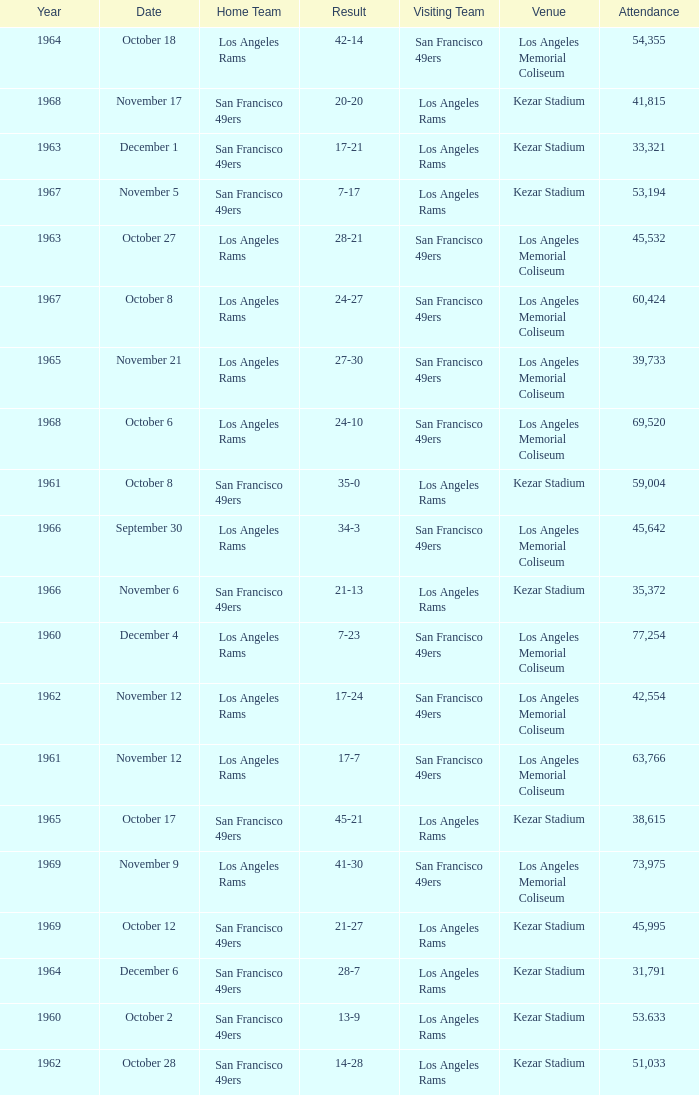When was the earliest year when the attendance was 77,254? 1960.0. 